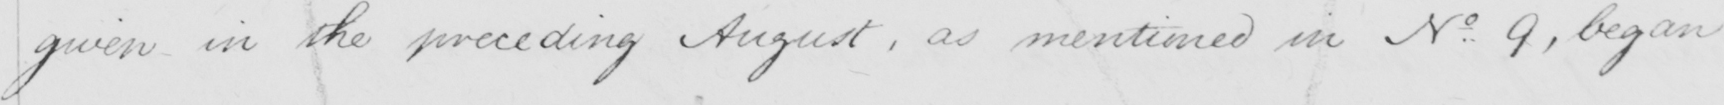Transcribe the text shown in this historical manuscript line. given in the preceding August , as mentioned in N . 9 , began 